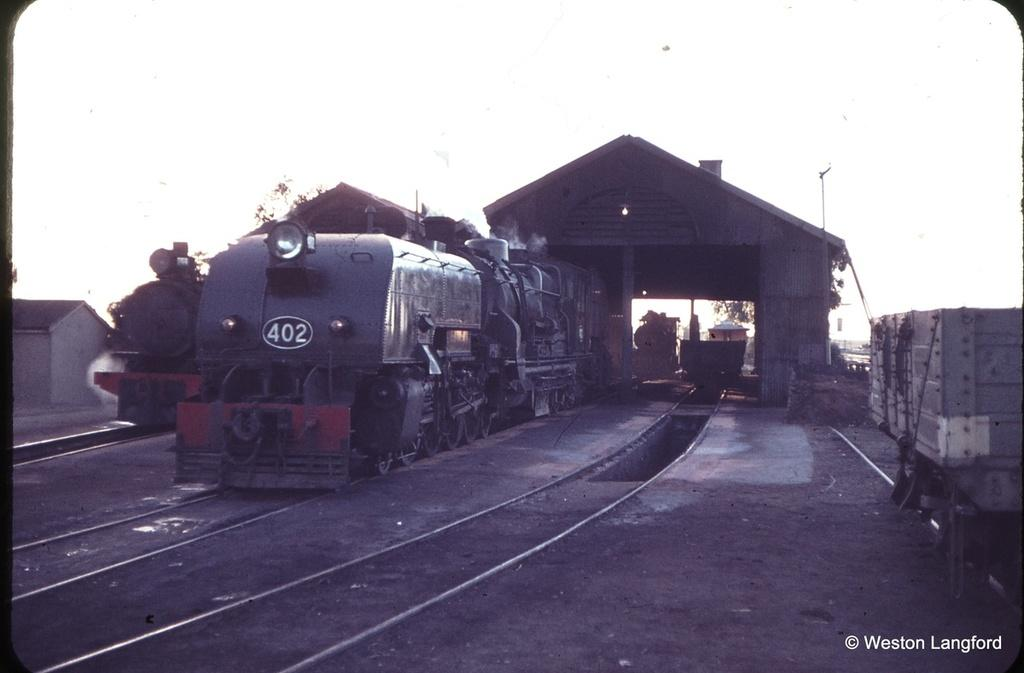What type of vehicles can be seen in the image? There are trains on railway tracks in the image. What structures are present in the image for shelter or protection? There are shelters in the image. What type of natural vegetation is visible in the image? There are trees in the image. What type of building can be seen in the image? There is a house in the image. Can you describe any unspecified objects in the image? There are some unspecified objects in the image, but their purpose or appearance cannot be determined from the provided facts. What can be seen in the background of the image? The sky is visible in the background of the image. How does the island in the image affect the train's movement? There is no island present in the image; it features trains on railway tracks, shelters, trees, a house, unspecified objects, and a visible sky. What message of hope can be found in the image? The image does not convey a specific message of hope; it simply depicts trains, shelters, trees, a house, unspecified objects, and a visible sky. 